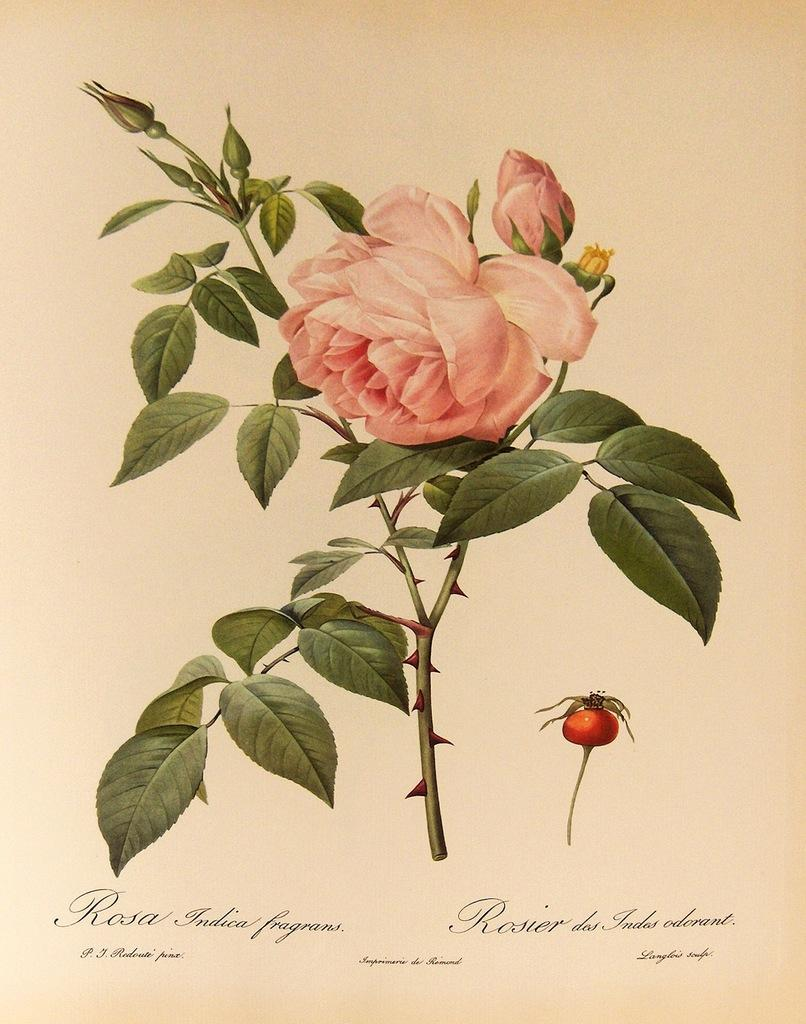What type of artwork is depicted in the image? The image is a painting. What is the main subject of the painting? There is a flower plant in the center of the painting. Is there any text included in the painting? Yes, there is text printed at the bottom of the painting. What type of quartz can be seen in the painting? There is no quartz present in the painting; it features a flower plant and text. How does the worm interact with the flower plant in the painting? There is no worm present in the painting; it only features a flower plant and text. 